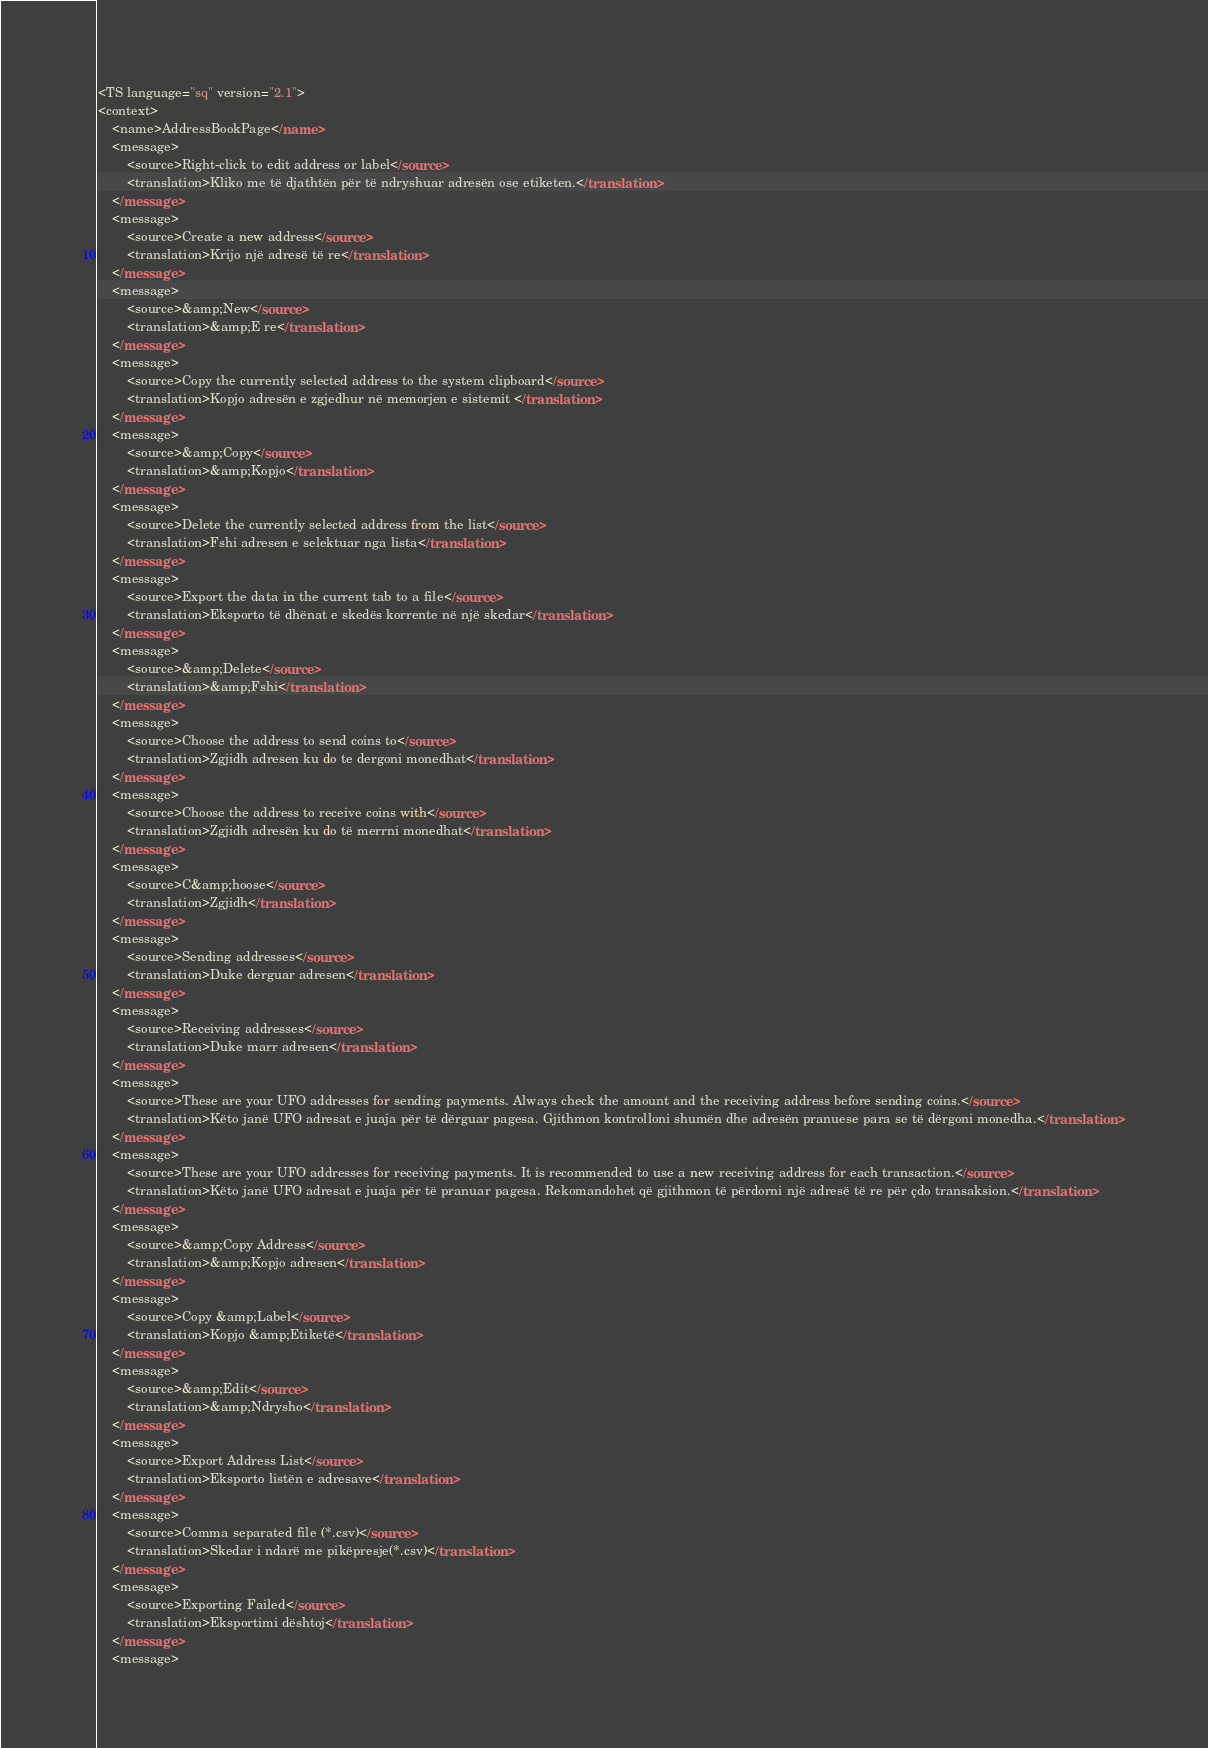Convert code to text. <code><loc_0><loc_0><loc_500><loc_500><_TypeScript_><TS language="sq" version="2.1">
<context>
    <name>AddressBookPage</name>
    <message>
        <source>Right-click to edit address or label</source>
        <translation>Kliko me të djathtën për të ndryshuar adresën ose etiketen.</translation>
    </message>
    <message>
        <source>Create a new address</source>
        <translation>Krijo një adresë të re</translation>
    </message>
    <message>
        <source>&amp;New</source>
        <translation>&amp;E re</translation>
    </message>
    <message>
        <source>Copy the currently selected address to the system clipboard</source>
        <translation>Kopjo adresën e zgjedhur në memorjen e sistemit </translation>
    </message>
    <message>
        <source>&amp;Copy</source>
        <translation>&amp;Kopjo</translation>
    </message>
    <message>
        <source>Delete the currently selected address from the list</source>
        <translation>Fshi adresen e selektuar nga lista</translation>
    </message>
    <message>
        <source>Export the data in the current tab to a file</source>
        <translation>Eksporto të dhënat e skedës korrente në një skedar</translation>
    </message>
    <message>
        <source>&amp;Delete</source>
        <translation>&amp;Fshi</translation>
    </message>
    <message>
        <source>Choose the address to send coins to</source>
        <translation>Zgjidh adresen ku do te dergoni monedhat</translation>
    </message>
    <message>
        <source>Choose the address to receive coins with</source>
        <translation>Zgjidh adresën ku do të merrni monedhat</translation>
    </message>
    <message>
        <source>C&amp;hoose</source>
        <translation>Zgjidh</translation>
    </message>
    <message>
        <source>Sending addresses</source>
        <translation>Duke derguar adresen</translation>
    </message>
    <message>
        <source>Receiving addresses</source>
        <translation>Duke marr adresen</translation>
    </message>
    <message>
        <source>These are your UFO addresses for sending payments. Always check the amount and the receiving address before sending coins.</source>
        <translation>Këto janë UFO adresat e juaja për të dërguar pagesa. Gjithmon kontrolloni shumën dhe adresën pranuese para se të dërgoni monedha.</translation>
    </message>
    <message>
        <source>These are your UFO addresses for receiving payments. It is recommended to use a new receiving address for each transaction.</source>
        <translation>Këto janë UFO adresat e juaja për të pranuar pagesa. Rekomandohet që gjithmon të përdorni një adresë të re për çdo transaksion.</translation>
    </message>
    <message>
        <source>&amp;Copy Address</source>
        <translation>&amp;Kopjo adresen</translation>
    </message>
    <message>
        <source>Copy &amp;Label</source>
        <translation>Kopjo &amp;Etiketë</translation>
    </message>
    <message>
        <source>&amp;Edit</source>
        <translation>&amp;Ndrysho</translation>
    </message>
    <message>
        <source>Export Address List</source>
        <translation>Eksporto listën e adresave</translation>
    </message>
    <message>
        <source>Comma separated file (*.csv)</source>
        <translation>Skedar i ndarë me pikëpresje(*.csv)</translation>
    </message>
    <message>
        <source>Exporting Failed</source>
        <translation>Eksportimi dështoj</translation>
    </message>
    <message></code> 